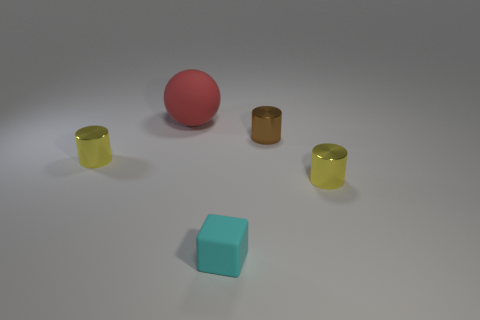Add 1 small cyan metallic cubes. How many objects exist? 6 Subtract all balls. How many objects are left? 4 Add 5 tiny yellow things. How many tiny yellow things exist? 7 Subtract 1 brown cylinders. How many objects are left? 4 Subtract all yellow cylinders. Subtract all small brown cylinders. How many objects are left? 2 Add 2 big balls. How many big balls are left? 3 